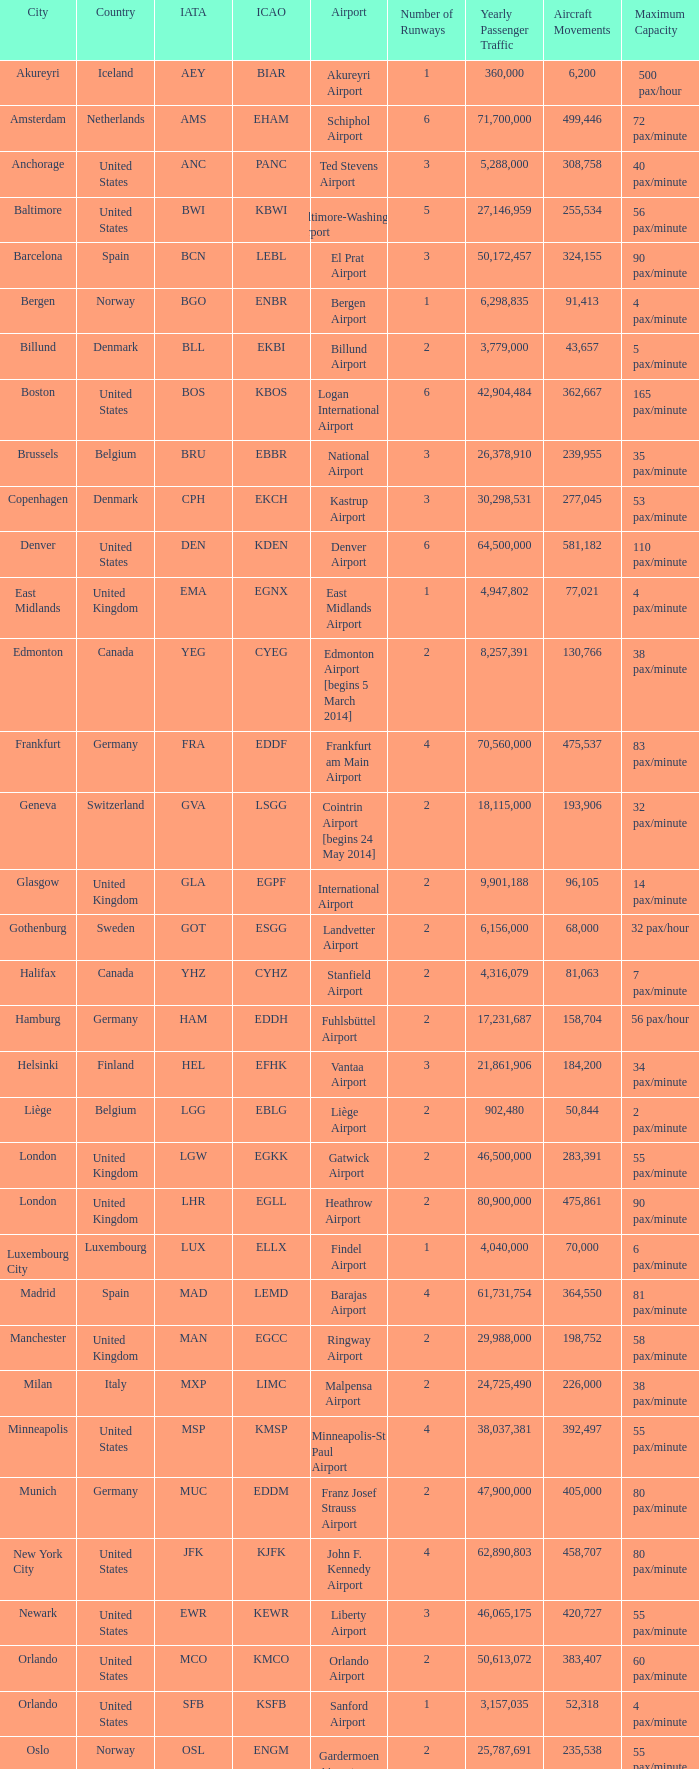Parse the full table. {'header': ['City', 'Country', 'IATA', 'ICAO', 'Airport', 'Number of Runways', 'Yearly Passenger Traffic', 'Aircraft Movements', 'Maximum Capacity'], 'rows': [['Akureyri', 'Iceland', 'AEY', 'BIAR', 'Akureyri Airport', '1', '360,000', '6,200', '500 pax/hour'], ['Amsterdam', 'Netherlands', 'AMS', 'EHAM', 'Schiphol Airport', '6', '71,700,000', '499,446', '72 pax/minute'], ['Anchorage', 'United States', 'ANC', 'PANC', 'Ted Stevens Airport', '3', '5,288,000', '308,758', '40 pax/minute'], ['Baltimore', 'United States', 'BWI', 'KBWI', 'Baltimore-Washington Airport', '5', '27,146,959', '255,534', '56 pax/minute'], ['Barcelona', 'Spain', 'BCN', 'LEBL', 'El Prat Airport', '3', '50,172,457', '324,155', '90 pax/minute'], ['Bergen', 'Norway', 'BGO', 'ENBR', 'Bergen Airport', '1', '6,298,835', '91,413', '4 pax/minute'], ['Billund', 'Denmark', 'BLL', 'EKBI', 'Billund Airport', '2', '3,779,000', '43,657', '5 pax/minute'], ['Boston', 'United States', 'BOS', 'KBOS', 'Logan International Airport', '6', '42,904,484', '362,667', '165 pax/minute'], ['Brussels', 'Belgium', 'BRU', 'EBBR', 'National Airport', '3', '26,378,910', '239,955', '35 pax/minute'], ['Copenhagen', 'Denmark', 'CPH', 'EKCH', 'Kastrup Airport', '3', '30,298,531', '277,045', '53 pax/minute'], ['Denver', 'United States', 'DEN', 'KDEN', 'Denver Airport', '6', '64,500,000', '581,182', '110 pax/minute'], ['East Midlands', 'United Kingdom', 'EMA', 'EGNX', 'East Midlands Airport', '1', '4,947,802', '77,021', '4 pax/minute'], ['Edmonton', 'Canada', 'YEG', 'CYEG', 'Edmonton Airport [begins 5 March 2014]', '2', '8,257,391', '130,766', '38 pax/minute'], ['Frankfurt', 'Germany', 'FRA', 'EDDF', 'Frankfurt am Main Airport', '4', '70,560,000', '475,537', '83 pax/minute'], ['Geneva', 'Switzerland', 'GVA', 'LSGG', 'Cointrin Airport [begins 24 May 2014]', '2', '18,115,000', '193,906', '32 pax/minute'], ['Glasgow', 'United Kingdom', 'GLA', 'EGPF', 'International Airport', '2', '9,901,188', '96,105', '14 pax/minute'], ['Gothenburg', 'Sweden', 'GOT', 'ESGG', 'Landvetter Airport', '2', '6,156,000', '68,000', '32 pax/hour'], ['Halifax', 'Canada', 'YHZ', 'CYHZ', 'Stanfield Airport', '2', '4,316,079', '81,063', '7 pax/minute'], ['Hamburg', 'Germany', 'HAM', 'EDDH', 'Fuhlsbüttel Airport', '2', '17,231,687', '158,704', '56 pax/hour'], ['Helsinki', 'Finland', 'HEL', 'EFHK', 'Vantaa Airport', '3', '21,861,906', '184,200', '34 pax/minute'], ['Liège', 'Belgium', 'LGG', 'EBLG', 'Liège Airport', '2', '902,480', '50,844', '2 pax/minute'], ['London', 'United Kingdom', 'LGW', 'EGKK', 'Gatwick Airport', '2', '46,500,000', '283,391', '55 pax/minute'], ['London', 'United Kingdom', 'LHR', 'EGLL', 'Heathrow Airport', '2', '80,900,000', '475,861', '90 pax/minute'], ['Luxembourg City', 'Luxembourg', 'LUX', 'ELLX', 'Findel Airport', '1', '4,040,000', '70,000', '6 pax/minute'], ['Madrid', 'Spain', 'MAD', 'LEMD', 'Barajas Airport', '4', '61,731,754', '364,550', '81 pax/minute'], ['Manchester', 'United Kingdom', 'MAN', 'EGCC', 'Ringway Airport', '2', '29,988,000', '198,752', '58 pax/minute'], ['Milan', 'Italy', 'MXP', 'LIMC', 'Malpensa Airport', '2', '24,725,490', '226,000', '38 pax/minute'], ['Minneapolis', 'United States', 'MSP', 'KMSP', 'Minneapolis-St Paul Airport', '4', '38,037,381', '392,497', '55 pax/minute'], ['Munich', 'Germany', 'MUC', 'EDDM', 'Franz Josef Strauss Airport', '2', '47,900,000', '405,000', '80 pax/minute'], ['New York City', 'United States', 'JFK', 'KJFK', 'John F. Kennedy Airport', '4', '62,890,803', '458,707', '80 pax/minute'], ['Newark', 'United States', 'EWR', 'KEWR', 'Liberty Airport', '3', '46,065,175', '420,727', '55 pax/minute'], ['Orlando', 'United States', 'MCO', 'KMCO', 'Orlando Airport', '2', '50,613,072', '383,407', '60 pax/minute'], ['Orlando', 'United States', 'SFB', 'KSFB', 'Sanford Airport', '1', '3,157,035', '52,318', '4 pax/minute'], ['Oslo', 'Norway', 'OSL', 'ENGM', 'Gardermoen Airport', '2', '25,787,691', '235,538', '55 pax/minute'], ['Paris', 'France', 'CDG', 'LFPG', 'Charles de Gaulle Airport', '4', '72,229,723', '475,654', '95 pax/minute'], ['Reykjavík', 'Iceland', 'KEF', 'BIKF', 'Keflavik Airport', '1', '8,755,000', '84,200', '8 pax/minute'], ['Saint Petersburg', 'Russia', 'LED', 'ULLI', 'Pulkovo Airport', '3', '19,951,000', '166,000', '24 pax/minute'], ['San Francisco', 'United States', 'SFO', 'KSFO', 'San Francisco Airport', '4', '57,793,313', '470,755', '80 pax/minute'], ['Seattle', 'United States', 'SEA', 'KSEA', 'Seattle–Tacoma Airport', '3', '49,849,520', '425,800', '70 pax/minute'], ['Stavanger', 'Norway', 'SVG', 'ENZV', 'Sola Airport', '1', '4,664,919', '65,571', '10 pax/hour'], ['Stockholm', 'Sweden', 'ARN', 'ESSA', 'Arlanda Airport', '4', '25,946,000', '216,000', '35 pax/minute'], ['Toronto', 'Canada', 'YYZ', 'CYYZ', 'Pearson Airport', '5', '49,507,418', '468,480', '135 pax/minute'], ['Trondheim', 'Norway', 'TRD', 'ENVA', 'Trondheim Airport', '1', '4,880,000', '69,091', '5 pax/minute'], ['Vancouver', 'Canada', 'YVR', 'CYVR', 'Vancouver Airport [begins 13 May 2014]', '3', '25,936,000', '332,277', '60 pax/minute'], ['Washington, D.C.', 'United States', 'IAD', 'KIAD', 'Dulles Airport', '2', '24,097,044', '215,399', '60 pax/minute'], ['Zurich', 'Switzerland', 'ZRH', 'LSZH', 'Kloten Airport', '3', '31,150,000', '267,504', '66 pax/minute']]} What is the IcAO of Frankfurt? EDDF. 